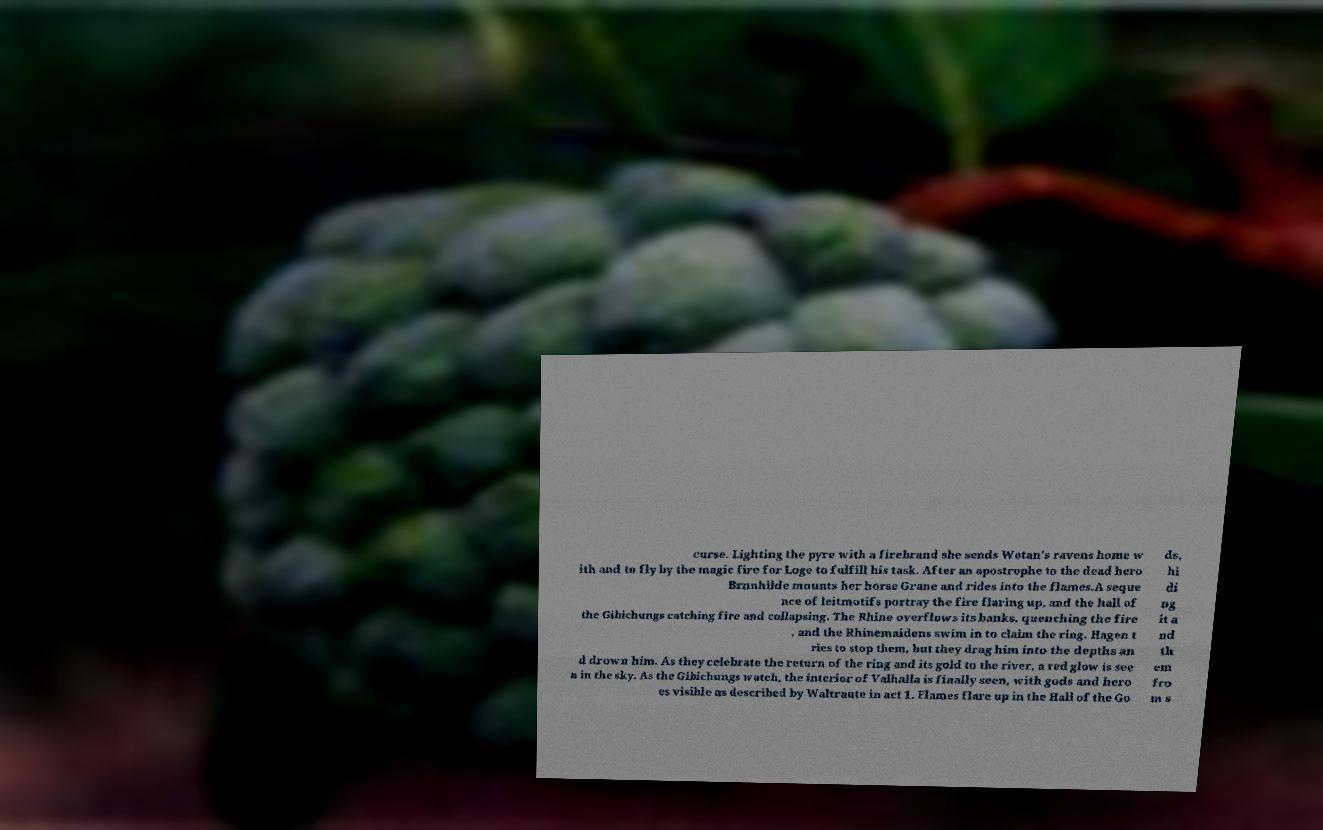Can you accurately transcribe the text from the provided image for me? curse. Lighting the pyre with a firebrand she sends Wotan's ravens home w ith and to fly by the magic fire for Loge to fulfill his task. After an apostrophe to the dead hero Brnnhilde mounts her horse Grane and rides into the flames.A seque nce of leitmotifs portray the fire flaring up, and the hall of the Gibichungs catching fire and collapsing. The Rhine overflows its banks, quenching the fire , and the Rhinemaidens swim in to claim the ring. Hagen t ries to stop them, but they drag him into the depths an d drown him. As they celebrate the return of the ring and its gold to the river, a red glow is see n in the sky. As the Gibichungs watch, the interior of Valhalla is finally seen, with gods and hero es visible as described by Waltraute in act 1. Flames flare up in the Hall of the Go ds, hi di ng it a nd th em fro m s 